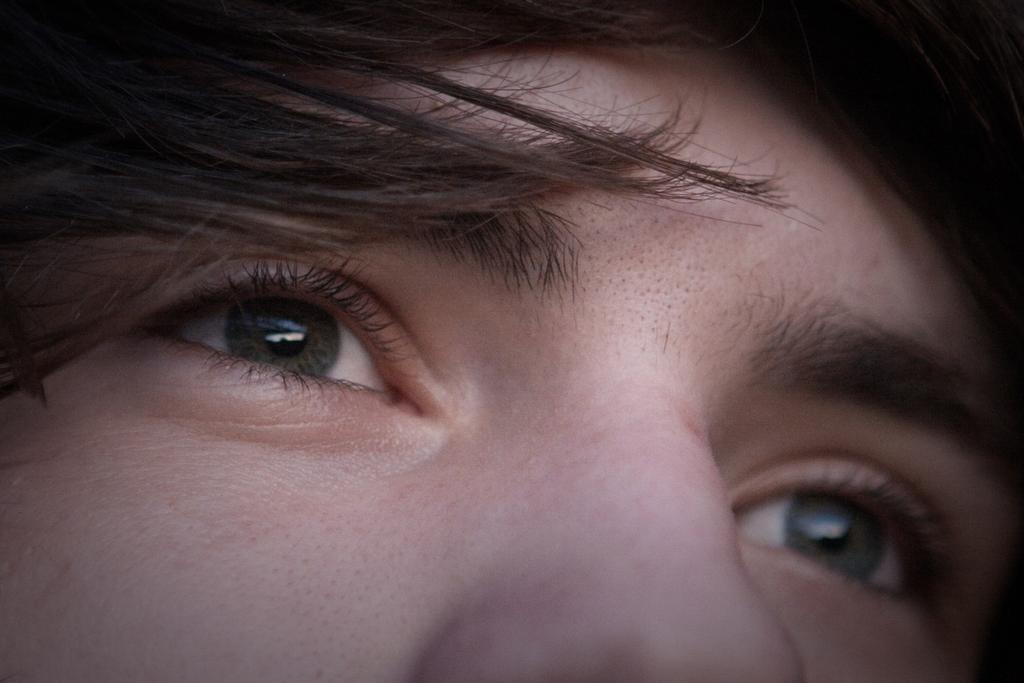What body part is the main focus of the image? The main focus of the image is human eyes. What other facial features can be seen in the image? There is hair and a nose visible in the image. What type of game is being played in the image? There is no game present in the image; it features human eyes, hair, and a nose. How many cubs are visible in the image? There are no cubs present in the image. 